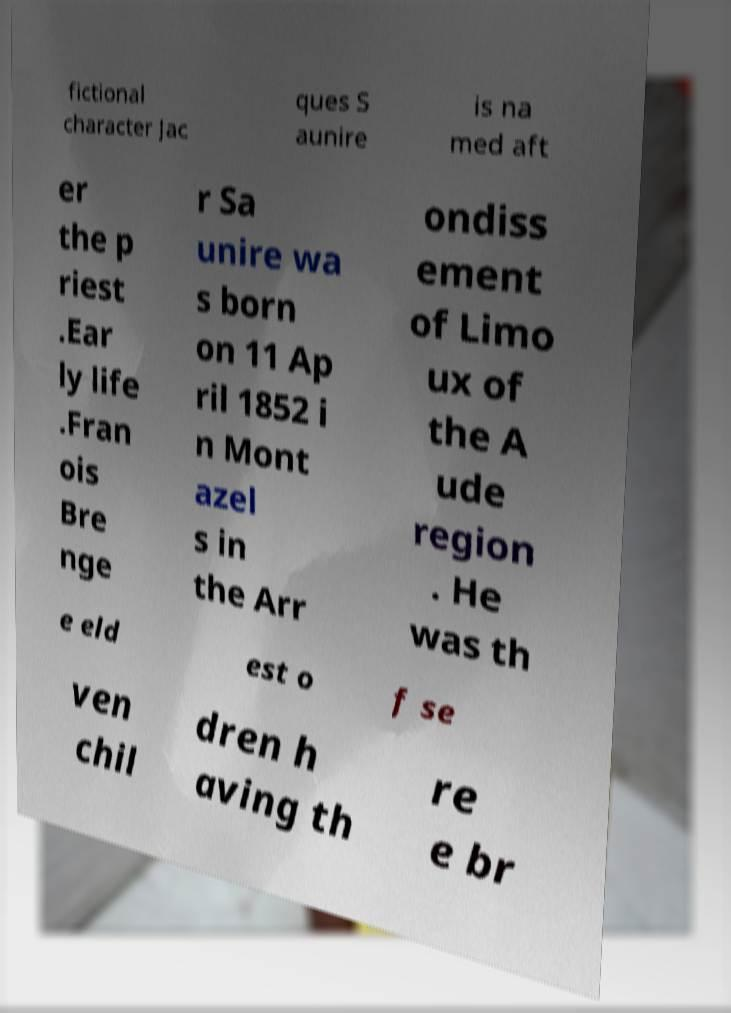Could you extract and type out the text from this image? fictional character Jac ques S aunire is na med aft er the p riest .Ear ly life .Fran ois Bre nge r Sa unire wa s born on 11 Ap ril 1852 i n Mont azel s in the Arr ondiss ement of Limo ux of the A ude region . He was th e eld est o f se ven chil dren h aving th re e br 